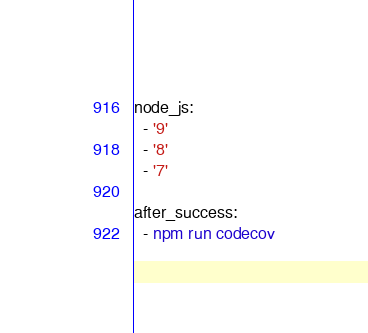Convert code to text. <code><loc_0><loc_0><loc_500><loc_500><_YAML_>node_js:
  - '9'
  - '8'
  - '7'

after_success:
  - npm run codecov</code> 